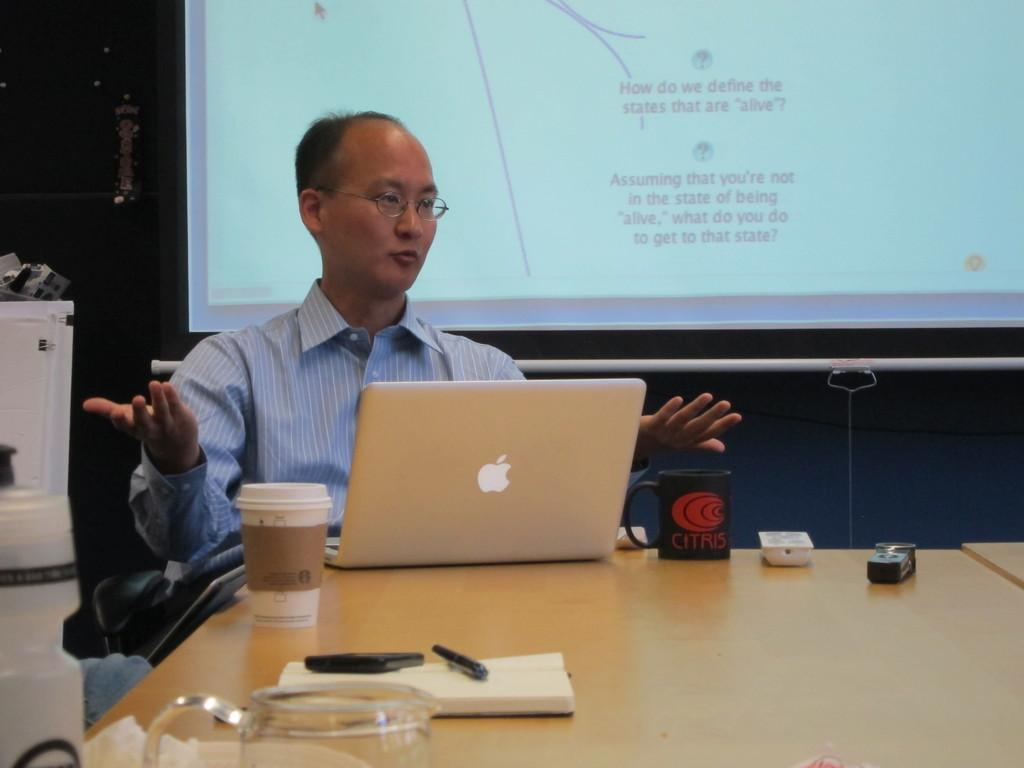Who is present in the image? There is a man in the image. What is the man doing in the image? The man is sitting in the image. Where is the man located in relation to the table? The man is in front of a table in the image. What items can be seen on the table? There are cups, a remote, a book, and a laptop on the table in the image. What is visible in the background of the image? There is a screen visible in the background of the image. How many letters does the man receive in the image? There are no letters present in the image. Can you describe the kiss between the man and the woman in the image? There is no woman or kiss present in the image; it only features a man sitting in front of a table. 